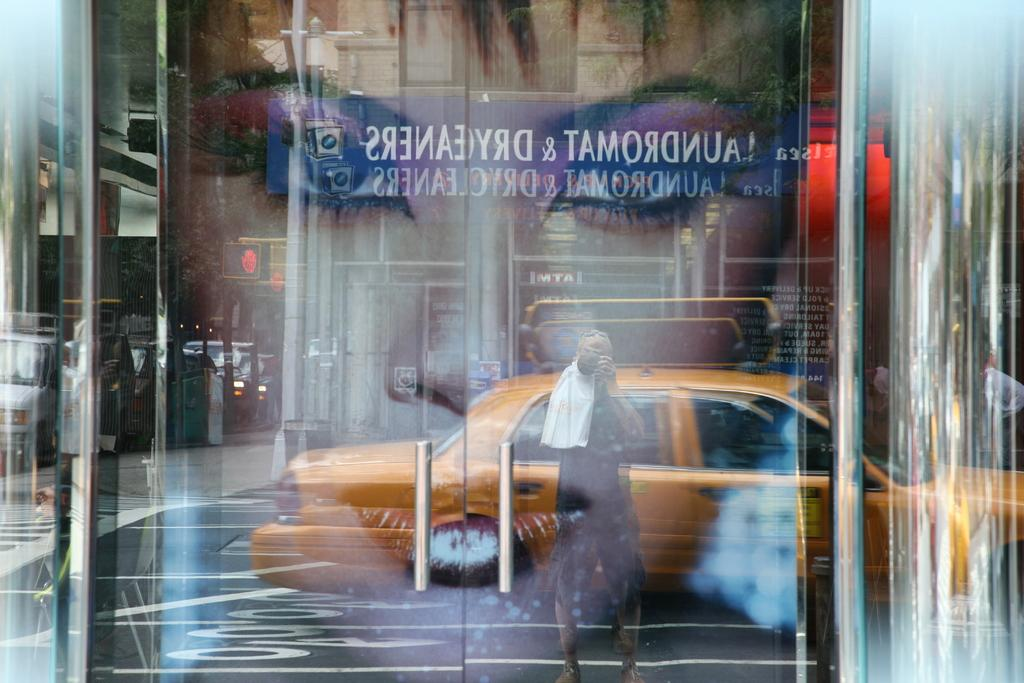What type of door is visible in the image? There is a glass door in the image. What is unique about the glass door? The glass door has a picture on it. What can be seen in the picture on the glass door? The picture on the glass door includes a person and a car. Where is the zoo located in the image? There is no zoo present in the image. What type of soda is being served in the image? There is no soda present in the image. 